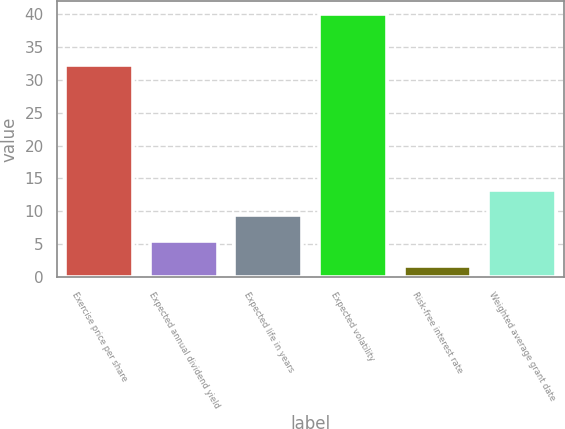Convert chart to OTSL. <chart><loc_0><loc_0><loc_500><loc_500><bar_chart><fcel>Exercise price per share<fcel>Expected annual dividend yield<fcel>Expected life in years<fcel>Expected volatility<fcel>Risk-free interest rate<fcel>Weighted average grant date<nl><fcel>32.3<fcel>5.53<fcel>9.36<fcel>40<fcel>1.7<fcel>13.19<nl></chart> 